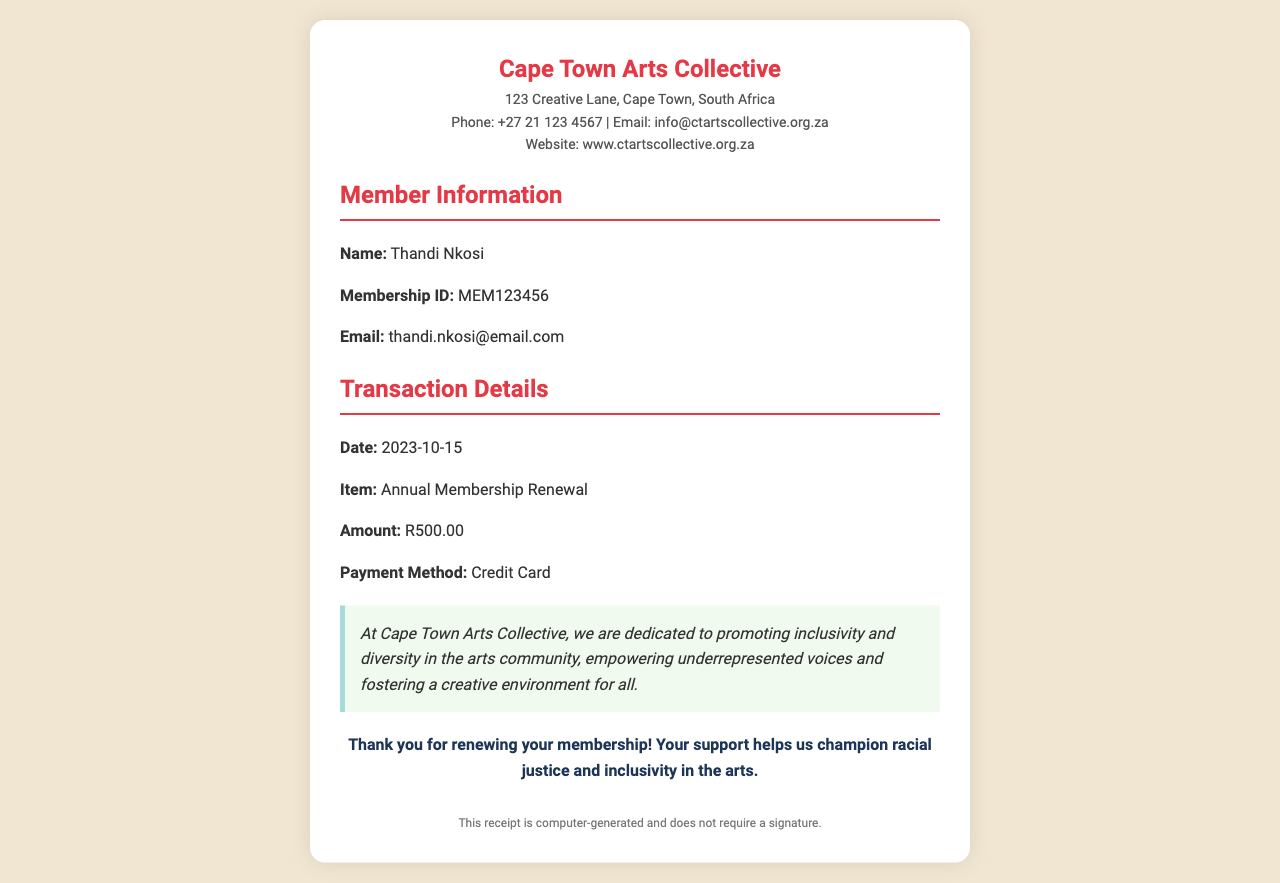What is the organization’s name? The name of the organization is clearly stated in the header section of the receipt.
Answer: Cape Town Arts Collective What is the membership ID? The membership ID is provided in the member information section of the receipt.
Answer: MEM123456 When was the membership renewed? The date of the transaction is specified in the transaction details.
Answer: 2023-10-15 What is the renewal amount? The amount for the annual membership renewal is stated in the transaction details.
Answer: R500.00 What payment method was used? The payment method can be found in the transaction details section of the receipt.
Answer: Credit Card What is the mission of the organization? The mission is outlined in a specific section that describes their goals and commitment.
Answer: promoting inclusivity and diversity in the arts community Who is the member? The name of the member is clearly mentioned in the member information section.
Answer: Thandi Nkosi What does the organization fight for? The receipt includes a statement about what the organization champions, reflecting its values.
Answer: racial justice and inclusivity in the arts What is the document type? The title of the document indicates what type of document it is.
Answer: Membership Renewal Receipt 